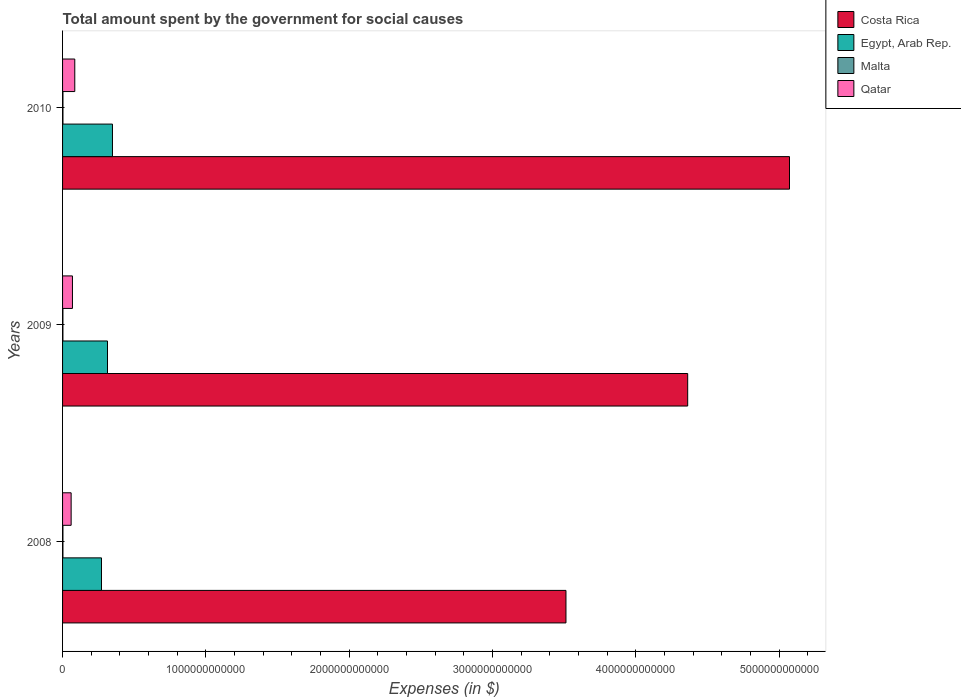How many different coloured bars are there?
Your response must be concise. 4. Are the number of bars on each tick of the Y-axis equal?
Ensure brevity in your answer.  Yes. How many bars are there on the 2nd tick from the top?
Provide a short and direct response. 4. How many bars are there on the 1st tick from the bottom?
Your answer should be compact. 4. What is the amount spent for social causes by the government in Qatar in 2008?
Ensure brevity in your answer.  5.98e+1. Across all years, what is the maximum amount spent for social causes by the government in Egypt, Arab Rep.?
Your answer should be compact. 3.48e+11. Across all years, what is the minimum amount spent for social causes by the government in Qatar?
Your answer should be compact. 5.98e+1. What is the total amount spent for social causes by the government in Costa Rica in the graph?
Your answer should be very brief. 1.29e+13. What is the difference between the amount spent for social causes by the government in Costa Rica in 2009 and that in 2010?
Your response must be concise. -7.10e+11. What is the difference between the amount spent for social causes by the government in Egypt, Arab Rep. in 2010 and the amount spent for social causes by the government in Qatar in 2009?
Offer a very short reply. 2.79e+11. What is the average amount spent for social causes by the government in Malta per year?
Give a very brief answer. 2.58e+09. In the year 2010, what is the difference between the amount spent for social causes by the government in Qatar and amount spent for social causes by the government in Malta?
Make the answer very short. 8.26e+1. In how many years, is the amount spent for social causes by the government in Costa Rica greater than 4600000000000 $?
Offer a very short reply. 1. What is the ratio of the amount spent for social causes by the government in Malta in 2009 to that in 2010?
Keep it short and to the point. 0.95. Is the difference between the amount spent for social causes by the government in Qatar in 2008 and 2010 greater than the difference between the amount spent for social causes by the government in Malta in 2008 and 2010?
Make the answer very short. No. What is the difference between the highest and the second highest amount spent for social causes by the government in Qatar?
Provide a short and direct response. 1.63e+1. What is the difference between the highest and the lowest amount spent for social causes by the government in Egypt, Arab Rep.?
Keep it short and to the point. 7.67e+1. Is the sum of the amount spent for social causes by the government in Costa Rica in 2008 and 2009 greater than the maximum amount spent for social causes by the government in Malta across all years?
Provide a succinct answer. Yes. Is it the case that in every year, the sum of the amount spent for social causes by the government in Qatar and amount spent for social causes by the government in Egypt, Arab Rep. is greater than the sum of amount spent for social causes by the government in Costa Rica and amount spent for social causes by the government in Malta?
Offer a very short reply. Yes. What does the 1st bar from the top in 2010 represents?
Offer a very short reply. Qatar. What does the 4th bar from the bottom in 2008 represents?
Offer a terse response. Qatar. Are all the bars in the graph horizontal?
Ensure brevity in your answer.  Yes. How many years are there in the graph?
Your answer should be very brief. 3. What is the difference between two consecutive major ticks on the X-axis?
Your response must be concise. 1.00e+12. Does the graph contain grids?
Offer a terse response. No. How many legend labels are there?
Make the answer very short. 4. How are the legend labels stacked?
Offer a very short reply. Vertical. What is the title of the graph?
Make the answer very short. Total amount spent by the government for social causes. What is the label or title of the X-axis?
Keep it short and to the point. Expenses (in $). What is the label or title of the Y-axis?
Your answer should be compact. Years. What is the Expenses (in $) in Costa Rica in 2008?
Provide a short and direct response. 3.51e+12. What is the Expenses (in $) in Egypt, Arab Rep. in 2008?
Keep it short and to the point. 2.71e+11. What is the Expenses (in $) of Malta in 2008?
Your answer should be compact. 2.54e+09. What is the Expenses (in $) of Qatar in 2008?
Keep it short and to the point. 5.98e+1. What is the Expenses (in $) in Costa Rica in 2009?
Ensure brevity in your answer.  4.36e+12. What is the Expenses (in $) in Egypt, Arab Rep. in 2009?
Your answer should be very brief. 3.13e+11. What is the Expenses (in $) of Malta in 2009?
Your answer should be compact. 2.53e+09. What is the Expenses (in $) of Qatar in 2009?
Provide a succinct answer. 6.90e+1. What is the Expenses (in $) of Costa Rica in 2010?
Your answer should be compact. 5.07e+12. What is the Expenses (in $) in Egypt, Arab Rep. in 2010?
Offer a terse response. 3.48e+11. What is the Expenses (in $) in Malta in 2010?
Offer a very short reply. 2.66e+09. What is the Expenses (in $) of Qatar in 2010?
Keep it short and to the point. 8.53e+1. Across all years, what is the maximum Expenses (in $) in Costa Rica?
Give a very brief answer. 5.07e+12. Across all years, what is the maximum Expenses (in $) of Egypt, Arab Rep.?
Provide a succinct answer. 3.48e+11. Across all years, what is the maximum Expenses (in $) in Malta?
Offer a terse response. 2.66e+09. Across all years, what is the maximum Expenses (in $) of Qatar?
Your answer should be very brief. 8.53e+1. Across all years, what is the minimum Expenses (in $) in Costa Rica?
Provide a succinct answer. 3.51e+12. Across all years, what is the minimum Expenses (in $) in Egypt, Arab Rep.?
Give a very brief answer. 2.71e+11. Across all years, what is the minimum Expenses (in $) in Malta?
Ensure brevity in your answer.  2.53e+09. Across all years, what is the minimum Expenses (in $) of Qatar?
Keep it short and to the point. 5.98e+1. What is the total Expenses (in $) in Costa Rica in the graph?
Ensure brevity in your answer.  1.29e+13. What is the total Expenses (in $) in Egypt, Arab Rep. in the graph?
Offer a very short reply. 9.33e+11. What is the total Expenses (in $) in Malta in the graph?
Keep it short and to the point. 7.73e+09. What is the total Expenses (in $) in Qatar in the graph?
Provide a succinct answer. 2.14e+11. What is the difference between the Expenses (in $) in Costa Rica in 2008 and that in 2009?
Your answer should be very brief. -8.49e+11. What is the difference between the Expenses (in $) of Egypt, Arab Rep. in 2008 and that in 2009?
Keep it short and to the point. -4.20e+1. What is the difference between the Expenses (in $) of Malta in 2008 and that in 2009?
Give a very brief answer. 1.65e+07. What is the difference between the Expenses (in $) in Qatar in 2008 and that in 2009?
Provide a short and direct response. -9.17e+09. What is the difference between the Expenses (in $) in Costa Rica in 2008 and that in 2010?
Your response must be concise. -1.56e+12. What is the difference between the Expenses (in $) of Egypt, Arab Rep. in 2008 and that in 2010?
Your response must be concise. -7.67e+1. What is the difference between the Expenses (in $) of Malta in 2008 and that in 2010?
Offer a very short reply. -1.17e+08. What is the difference between the Expenses (in $) of Qatar in 2008 and that in 2010?
Offer a terse response. -2.54e+1. What is the difference between the Expenses (in $) in Costa Rica in 2009 and that in 2010?
Make the answer very short. -7.10e+11. What is the difference between the Expenses (in $) in Egypt, Arab Rep. in 2009 and that in 2010?
Offer a very short reply. -3.48e+1. What is the difference between the Expenses (in $) of Malta in 2009 and that in 2010?
Offer a terse response. -1.33e+08. What is the difference between the Expenses (in $) in Qatar in 2009 and that in 2010?
Your answer should be very brief. -1.63e+1. What is the difference between the Expenses (in $) of Costa Rica in 2008 and the Expenses (in $) of Egypt, Arab Rep. in 2009?
Offer a terse response. 3.20e+12. What is the difference between the Expenses (in $) in Costa Rica in 2008 and the Expenses (in $) in Malta in 2009?
Offer a terse response. 3.51e+12. What is the difference between the Expenses (in $) of Costa Rica in 2008 and the Expenses (in $) of Qatar in 2009?
Give a very brief answer. 3.44e+12. What is the difference between the Expenses (in $) in Egypt, Arab Rep. in 2008 and the Expenses (in $) in Malta in 2009?
Keep it short and to the point. 2.69e+11. What is the difference between the Expenses (in $) in Egypt, Arab Rep. in 2008 and the Expenses (in $) in Qatar in 2009?
Provide a succinct answer. 2.02e+11. What is the difference between the Expenses (in $) in Malta in 2008 and the Expenses (in $) in Qatar in 2009?
Provide a succinct answer. -6.65e+1. What is the difference between the Expenses (in $) in Costa Rica in 2008 and the Expenses (in $) in Egypt, Arab Rep. in 2010?
Your response must be concise. 3.16e+12. What is the difference between the Expenses (in $) of Costa Rica in 2008 and the Expenses (in $) of Malta in 2010?
Give a very brief answer. 3.51e+12. What is the difference between the Expenses (in $) of Costa Rica in 2008 and the Expenses (in $) of Qatar in 2010?
Provide a succinct answer. 3.43e+12. What is the difference between the Expenses (in $) in Egypt, Arab Rep. in 2008 and the Expenses (in $) in Malta in 2010?
Make the answer very short. 2.69e+11. What is the difference between the Expenses (in $) in Egypt, Arab Rep. in 2008 and the Expenses (in $) in Qatar in 2010?
Give a very brief answer. 1.86e+11. What is the difference between the Expenses (in $) in Malta in 2008 and the Expenses (in $) in Qatar in 2010?
Keep it short and to the point. -8.27e+1. What is the difference between the Expenses (in $) in Costa Rica in 2009 and the Expenses (in $) in Egypt, Arab Rep. in 2010?
Provide a succinct answer. 4.01e+12. What is the difference between the Expenses (in $) of Costa Rica in 2009 and the Expenses (in $) of Malta in 2010?
Provide a short and direct response. 4.36e+12. What is the difference between the Expenses (in $) in Costa Rica in 2009 and the Expenses (in $) in Qatar in 2010?
Your response must be concise. 4.28e+12. What is the difference between the Expenses (in $) in Egypt, Arab Rep. in 2009 and the Expenses (in $) in Malta in 2010?
Offer a very short reply. 3.11e+11. What is the difference between the Expenses (in $) in Egypt, Arab Rep. in 2009 and the Expenses (in $) in Qatar in 2010?
Keep it short and to the point. 2.28e+11. What is the difference between the Expenses (in $) of Malta in 2009 and the Expenses (in $) of Qatar in 2010?
Ensure brevity in your answer.  -8.27e+1. What is the average Expenses (in $) in Costa Rica per year?
Give a very brief answer. 4.32e+12. What is the average Expenses (in $) in Egypt, Arab Rep. per year?
Give a very brief answer. 3.11e+11. What is the average Expenses (in $) in Malta per year?
Your answer should be compact. 2.58e+09. What is the average Expenses (in $) in Qatar per year?
Ensure brevity in your answer.  7.14e+1. In the year 2008, what is the difference between the Expenses (in $) in Costa Rica and Expenses (in $) in Egypt, Arab Rep.?
Your response must be concise. 3.24e+12. In the year 2008, what is the difference between the Expenses (in $) in Costa Rica and Expenses (in $) in Malta?
Provide a short and direct response. 3.51e+12. In the year 2008, what is the difference between the Expenses (in $) of Costa Rica and Expenses (in $) of Qatar?
Your response must be concise. 3.45e+12. In the year 2008, what is the difference between the Expenses (in $) of Egypt, Arab Rep. and Expenses (in $) of Malta?
Keep it short and to the point. 2.69e+11. In the year 2008, what is the difference between the Expenses (in $) in Egypt, Arab Rep. and Expenses (in $) in Qatar?
Give a very brief answer. 2.12e+11. In the year 2008, what is the difference between the Expenses (in $) in Malta and Expenses (in $) in Qatar?
Provide a succinct answer. -5.73e+1. In the year 2009, what is the difference between the Expenses (in $) of Costa Rica and Expenses (in $) of Egypt, Arab Rep.?
Your answer should be compact. 4.05e+12. In the year 2009, what is the difference between the Expenses (in $) in Costa Rica and Expenses (in $) in Malta?
Your answer should be compact. 4.36e+12. In the year 2009, what is the difference between the Expenses (in $) in Costa Rica and Expenses (in $) in Qatar?
Your answer should be compact. 4.29e+12. In the year 2009, what is the difference between the Expenses (in $) in Egypt, Arab Rep. and Expenses (in $) in Malta?
Make the answer very short. 3.11e+11. In the year 2009, what is the difference between the Expenses (in $) of Egypt, Arab Rep. and Expenses (in $) of Qatar?
Provide a short and direct response. 2.44e+11. In the year 2009, what is the difference between the Expenses (in $) of Malta and Expenses (in $) of Qatar?
Offer a terse response. -6.65e+1. In the year 2010, what is the difference between the Expenses (in $) in Costa Rica and Expenses (in $) in Egypt, Arab Rep.?
Offer a very short reply. 4.72e+12. In the year 2010, what is the difference between the Expenses (in $) in Costa Rica and Expenses (in $) in Malta?
Provide a succinct answer. 5.07e+12. In the year 2010, what is the difference between the Expenses (in $) in Costa Rica and Expenses (in $) in Qatar?
Ensure brevity in your answer.  4.99e+12. In the year 2010, what is the difference between the Expenses (in $) in Egypt, Arab Rep. and Expenses (in $) in Malta?
Give a very brief answer. 3.46e+11. In the year 2010, what is the difference between the Expenses (in $) of Egypt, Arab Rep. and Expenses (in $) of Qatar?
Your answer should be very brief. 2.63e+11. In the year 2010, what is the difference between the Expenses (in $) of Malta and Expenses (in $) of Qatar?
Your answer should be very brief. -8.26e+1. What is the ratio of the Expenses (in $) of Costa Rica in 2008 to that in 2009?
Offer a very short reply. 0.81. What is the ratio of the Expenses (in $) of Egypt, Arab Rep. in 2008 to that in 2009?
Offer a very short reply. 0.87. What is the ratio of the Expenses (in $) in Malta in 2008 to that in 2009?
Provide a short and direct response. 1.01. What is the ratio of the Expenses (in $) of Qatar in 2008 to that in 2009?
Provide a succinct answer. 0.87. What is the ratio of the Expenses (in $) in Costa Rica in 2008 to that in 2010?
Your answer should be very brief. 0.69. What is the ratio of the Expenses (in $) of Egypt, Arab Rep. in 2008 to that in 2010?
Give a very brief answer. 0.78. What is the ratio of the Expenses (in $) of Malta in 2008 to that in 2010?
Provide a short and direct response. 0.96. What is the ratio of the Expenses (in $) of Qatar in 2008 to that in 2010?
Make the answer very short. 0.7. What is the ratio of the Expenses (in $) of Costa Rica in 2009 to that in 2010?
Give a very brief answer. 0.86. What is the ratio of the Expenses (in $) in Egypt, Arab Rep. in 2009 to that in 2010?
Ensure brevity in your answer.  0.9. What is the ratio of the Expenses (in $) of Malta in 2009 to that in 2010?
Keep it short and to the point. 0.95. What is the ratio of the Expenses (in $) of Qatar in 2009 to that in 2010?
Provide a succinct answer. 0.81. What is the difference between the highest and the second highest Expenses (in $) in Costa Rica?
Your response must be concise. 7.10e+11. What is the difference between the highest and the second highest Expenses (in $) in Egypt, Arab Rep.?
Ensure brevity in your answer.  3.48e+1. What is the difference between the highest and the second highest Expenses (in $) in Malta?
Provide a succinct answer. 1.17e+08. What is the difference between the highest and the second highest Expenses (in $) in Qatar?
Keep it short and to the point. 1.63e+1. What is the difference between the highest and the lowest Expenses (in $) of Costa Rica?
Your response must be concise. 1.56e+12. What is the difference between the highest and the lowest Expenses (in $) of Egypt, Arab Rep.?
Keep it short and to the point. 7.67e+1. What is the difference between the highest and the lowest Expenses (in $) of Malta?
Make the answer very short. 1.33e+08. What is the difference between the highest and the lowest Expenses (in $) of Qatar?
Make the answer very short. 2.54e+1. 